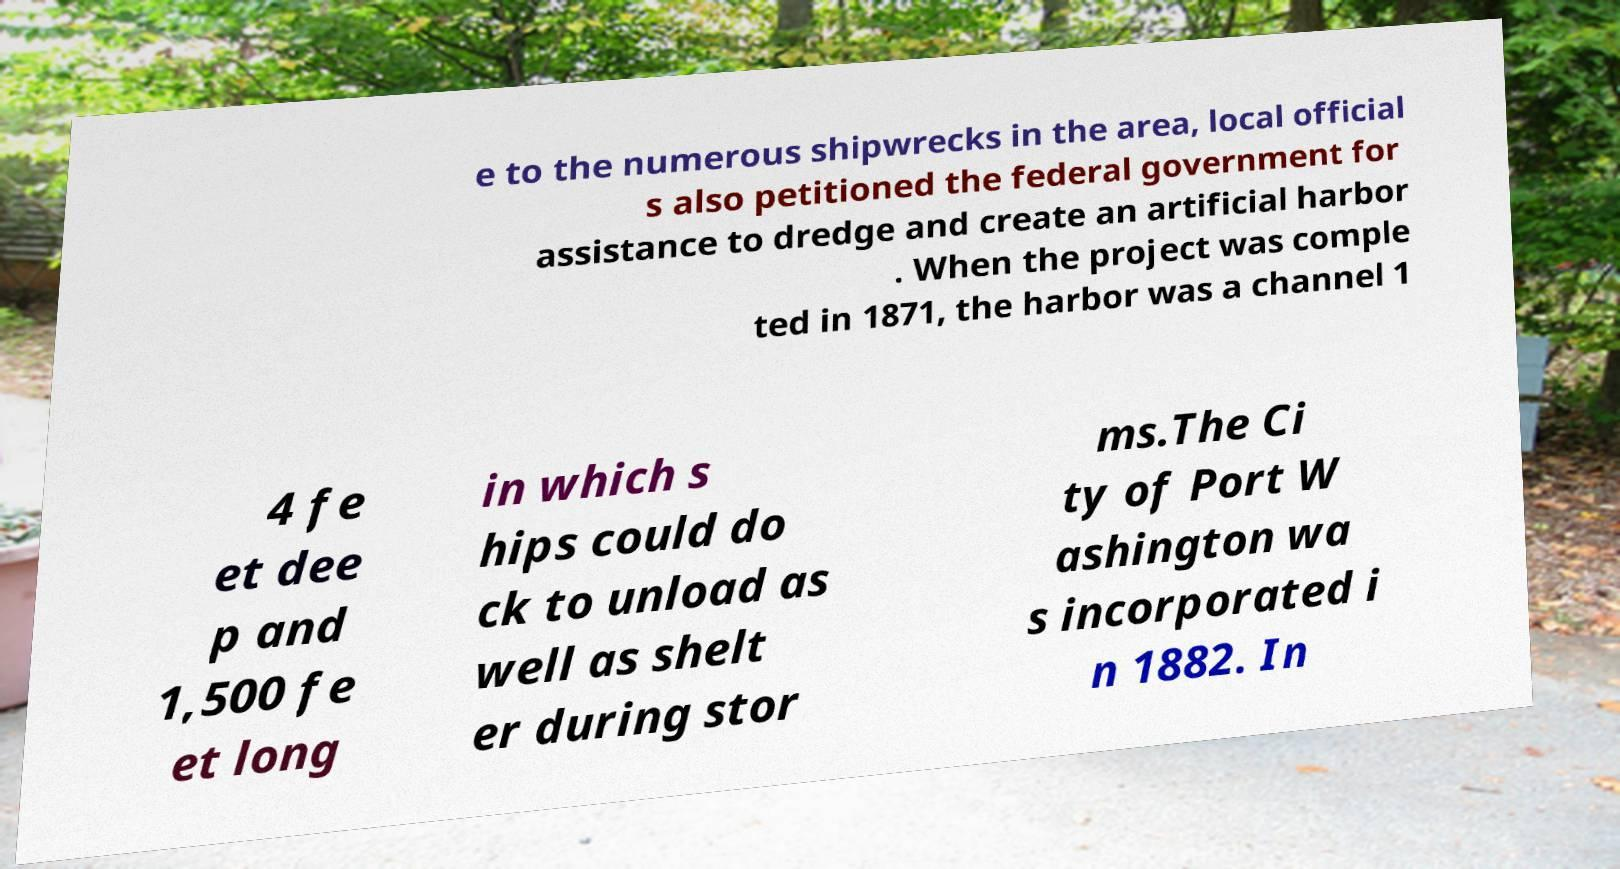What messages or text are displayed in this image? I need them in a readable, typed format. e to the numerous shipwrecks in the area, local official s also petitioned the federal government for assistance to dredge and create an artificial harbor . When the project was comple ted in 1871, the harbor was a channel 1 4 fe et dee p and 1,500 fe et long in which s hips could do ck to unload as well as shelt er during stor ms.The Ci ty of Port W ashington wa s incorporated i n 1882. In 